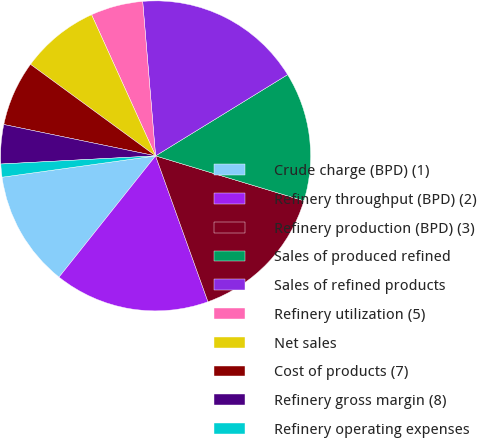Convert chart. <chart><loc_0><loc_0><loc_500><loc_500><pie_chart><fcel>Crude charge (BPD) (1)<fcel>Refinery throughput (BPD) (2)<fcel>Refinery production (BPD) (3)<fcel>Sales of produced refined<fcel>Sales of refined products<fcel>Refinery utilization (5)<fcel>Net sales<fcel>Cost of products (7)<fcel>Refinery gross margin (8)<fcel>Refinery operating expenses<nl><fcel>12.1%<fcel>16.19%<fcel>14.83%<fcel>13.46%<fcel>17.55%<fcel>5.45%<fcel>8.17%<fcel>6.81%<fcel>4.08%<fcel>1.36%<nl></chart> 